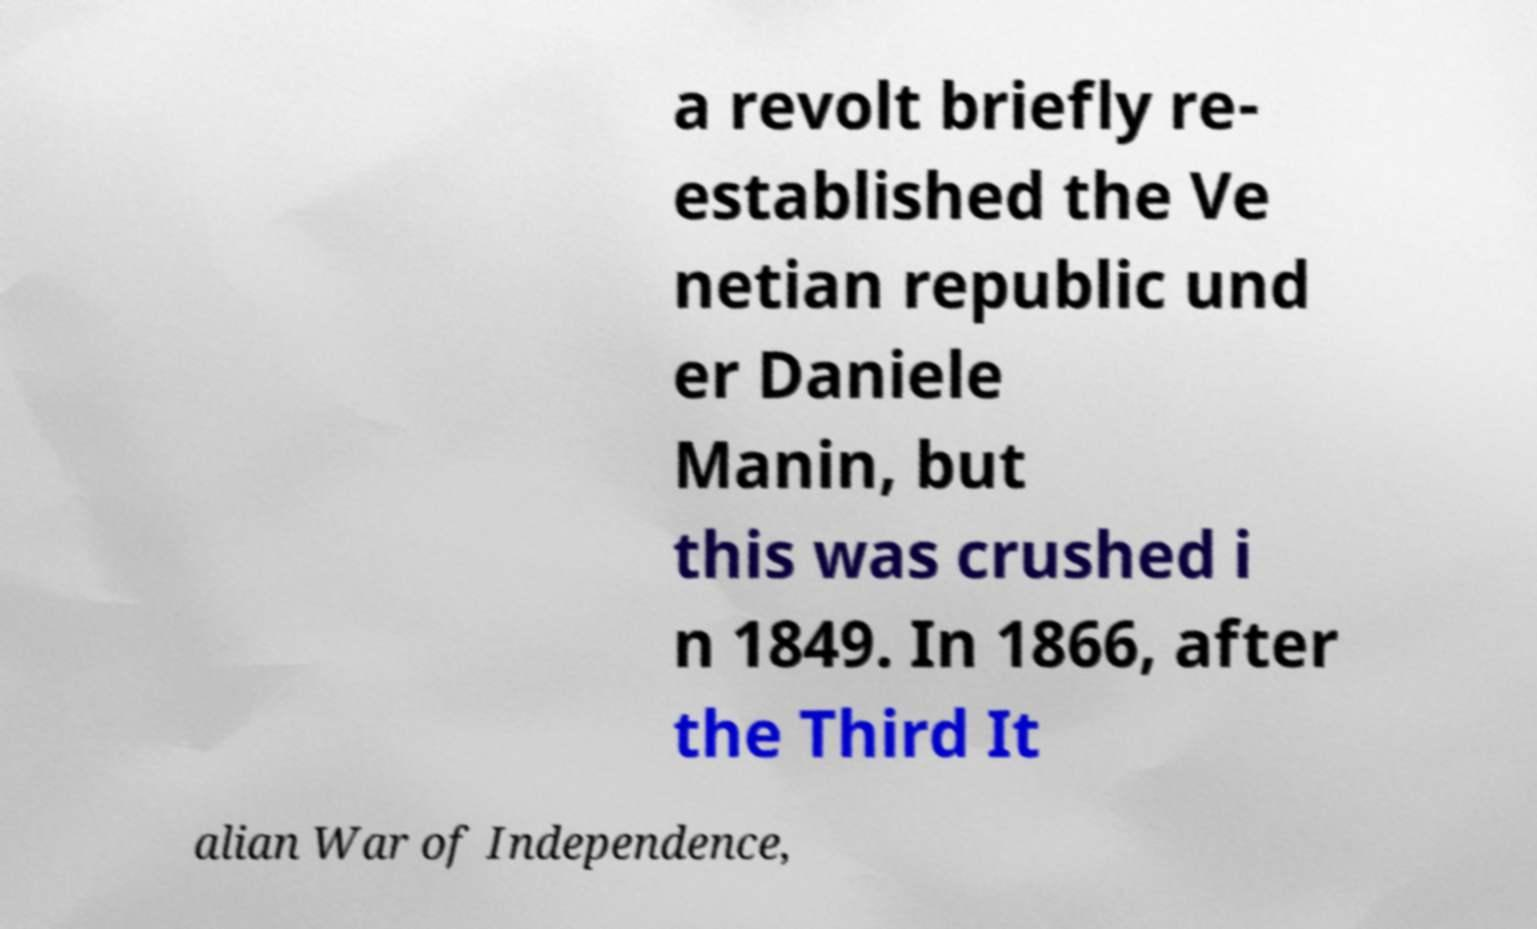Can you read and provide the text displayed in the image?This photo seems to have some interesting text. Can you extract and type it out for me? a revolt briefly re- established the Ve netian republic und er Daniele Manin, but this was crushed i n 1849. In 1866, after the Third It alian War of Independence, 